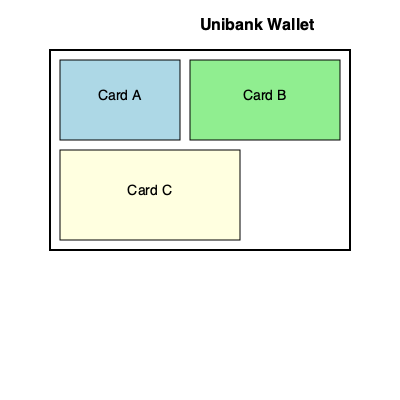As a long-time Unibank customer, you're presented with a new wallet design and three different sized bank cards. Card A measures 120x80 units, Card B is 150x80 units, and Card C is 180x90 units. The wallet has internal dimensions of 300x200 units. What is the maximum number of each card type that can fit in the wallet simultaneously without overlapping? To solve this spatial puzzle, let's approach it step-by-step:

1. First, we need to calculate the area of the wallet:
   Wallet area = $300 \times 200 = 60,000$ square units

2. Now, let's calculate the areas of each card:
   Card A: $120 \times 80 = 9,600$ square units
   Card B: $150 \times 80 = 12,000$ square units
   Card C: $180 \times 90 = 16,200$ square units

3. We need to maximize the number of cards while fitting them within the wallet's dimensions. Let's start with the largest card, Card C:
   - We can fit one Card C horizontally (180 < 300) and two vertically (90 × 2 = 180 < 200)
   - This means we can fit 2 Card C's, leaving 60,000 - (2 × 16,200) = 27,600 square units

4. For the remaining space, we can fit:
   - One Card B horizontally (150 < 300) and one vertically (80 < 100 remaining vertical space)
   - This leaves 27,600 - 12,000 = 15,600 square units

5. Finally, we can fit one Card A in the remaining space (120 × 80 < 15,600)

6. Therefore, the maximum number of cards that can fit simultaneously is:
   - 2 Card C
   - 1 Card B
   - 1 Card A
Answer: 2 C, 1 B, 1 A 